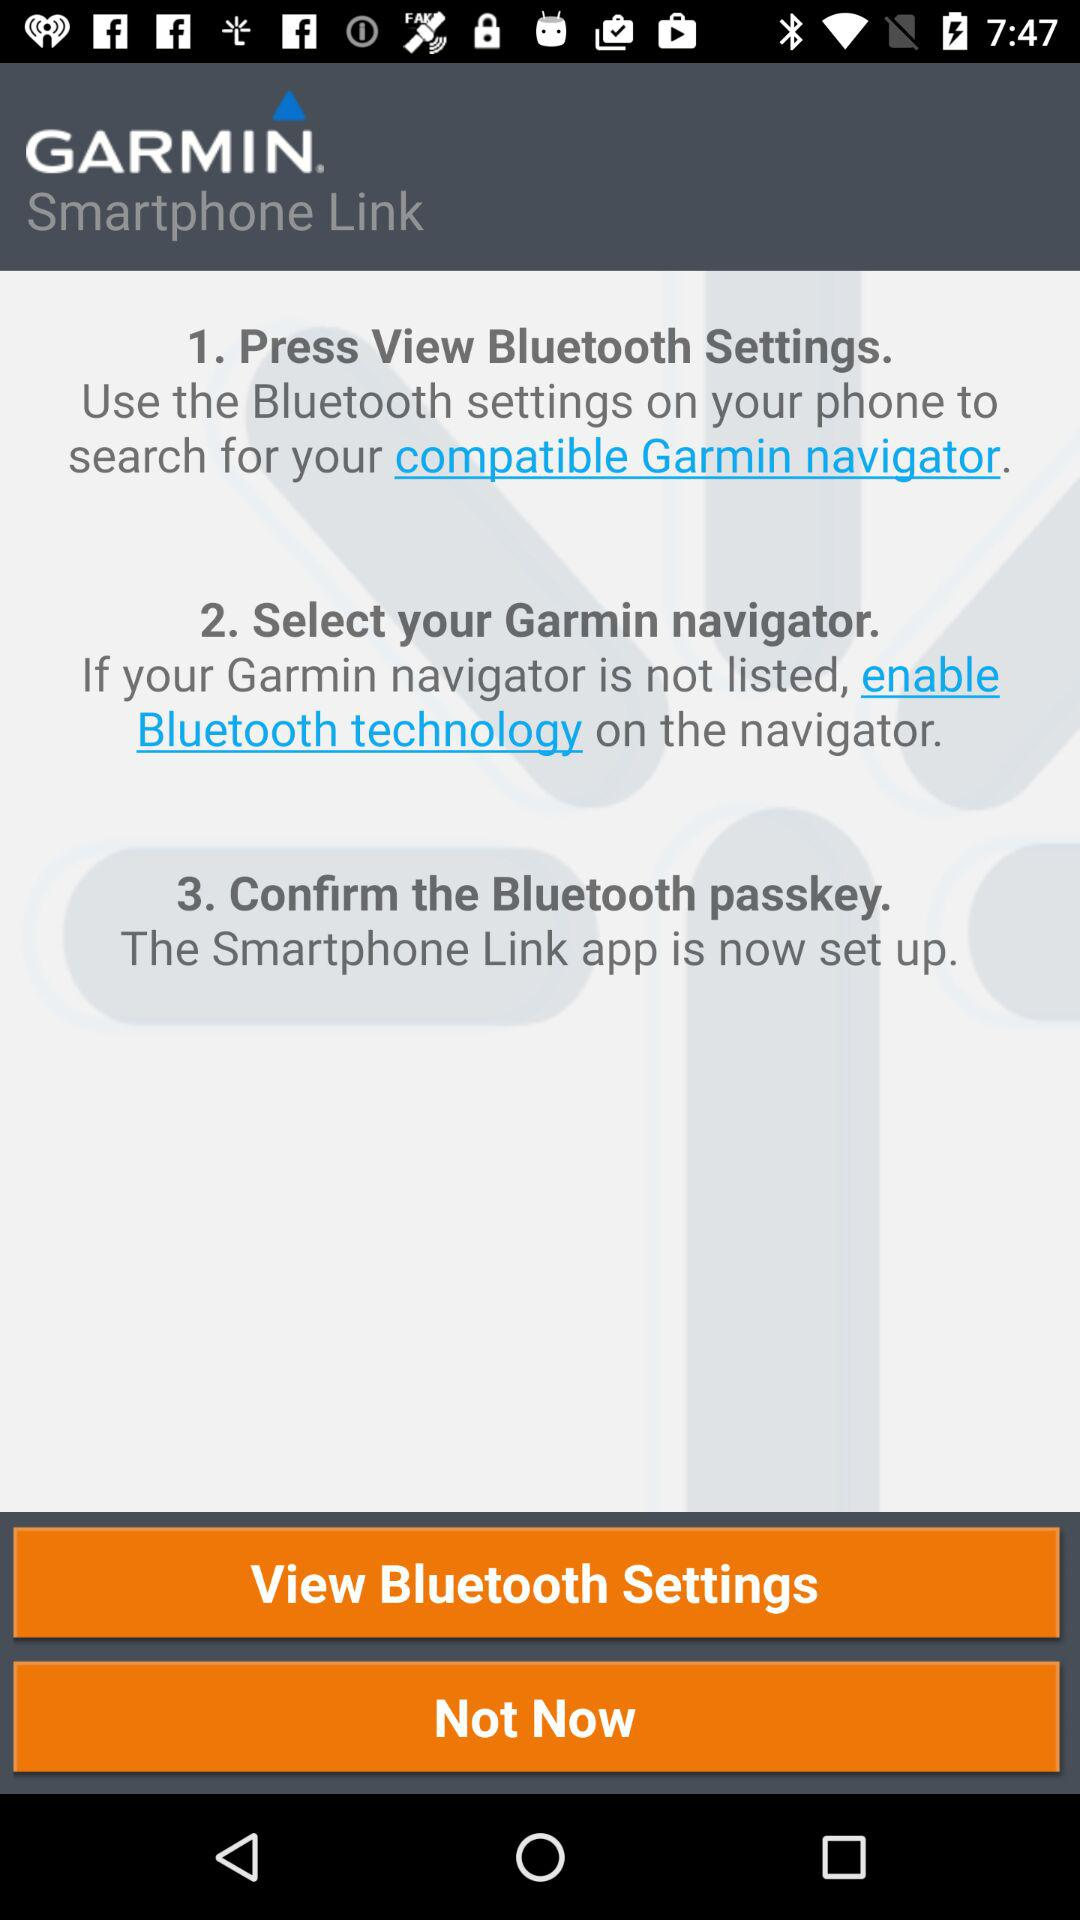What is the application name? The application name is "GARMIN Smartphone Link". 